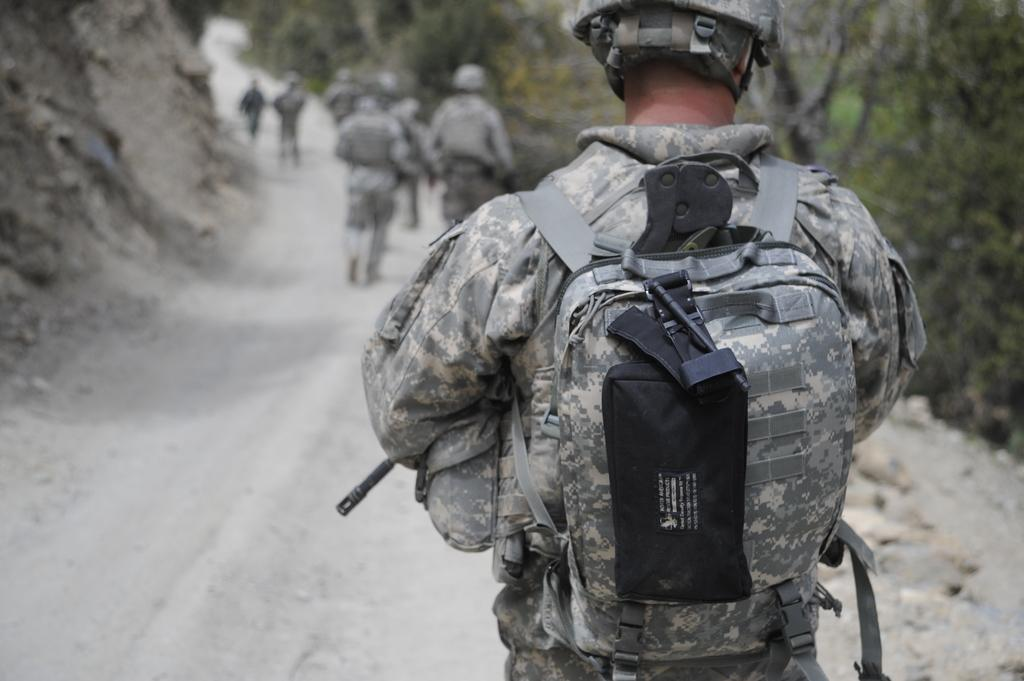What is the main subject of the image? The main subject of the image is a soldier. What is the soldier wearing? The soldier is wearing a bag and helmet. What is the soldier doing in the image? The soldier is walking on a road. How many soldiers are present in the image? There are multiple soldiers in the image. What can be seen in the background of the image? There are trees in the background of the image. What type of fish can be seen swimming in the background of the image? There are no fish present in the image; it features soldiers walking on a road with trees in the background. 